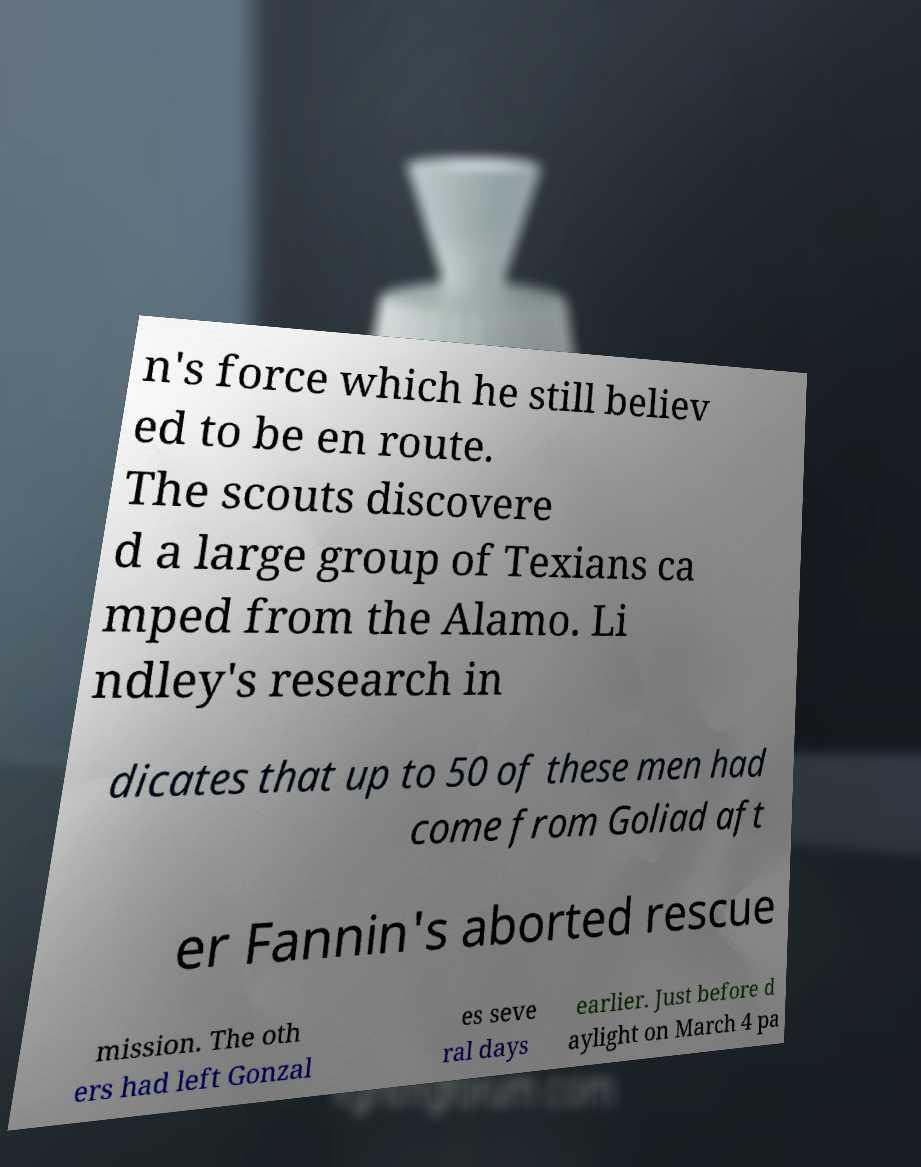What messages or text are displayed in this image? I need them in a readable, typed format. n's force which he still believ ed to be en route. The scouts discovere d a large group of Texians ca mped from the Alamo. Li ndley's research in dicates that up to 50 of these men had come from Goliad aft er Fannin's aborted rescue mission. The oth ers had left Gonzal es seve ral days earlier. Just before d aylight on March 4 pa 